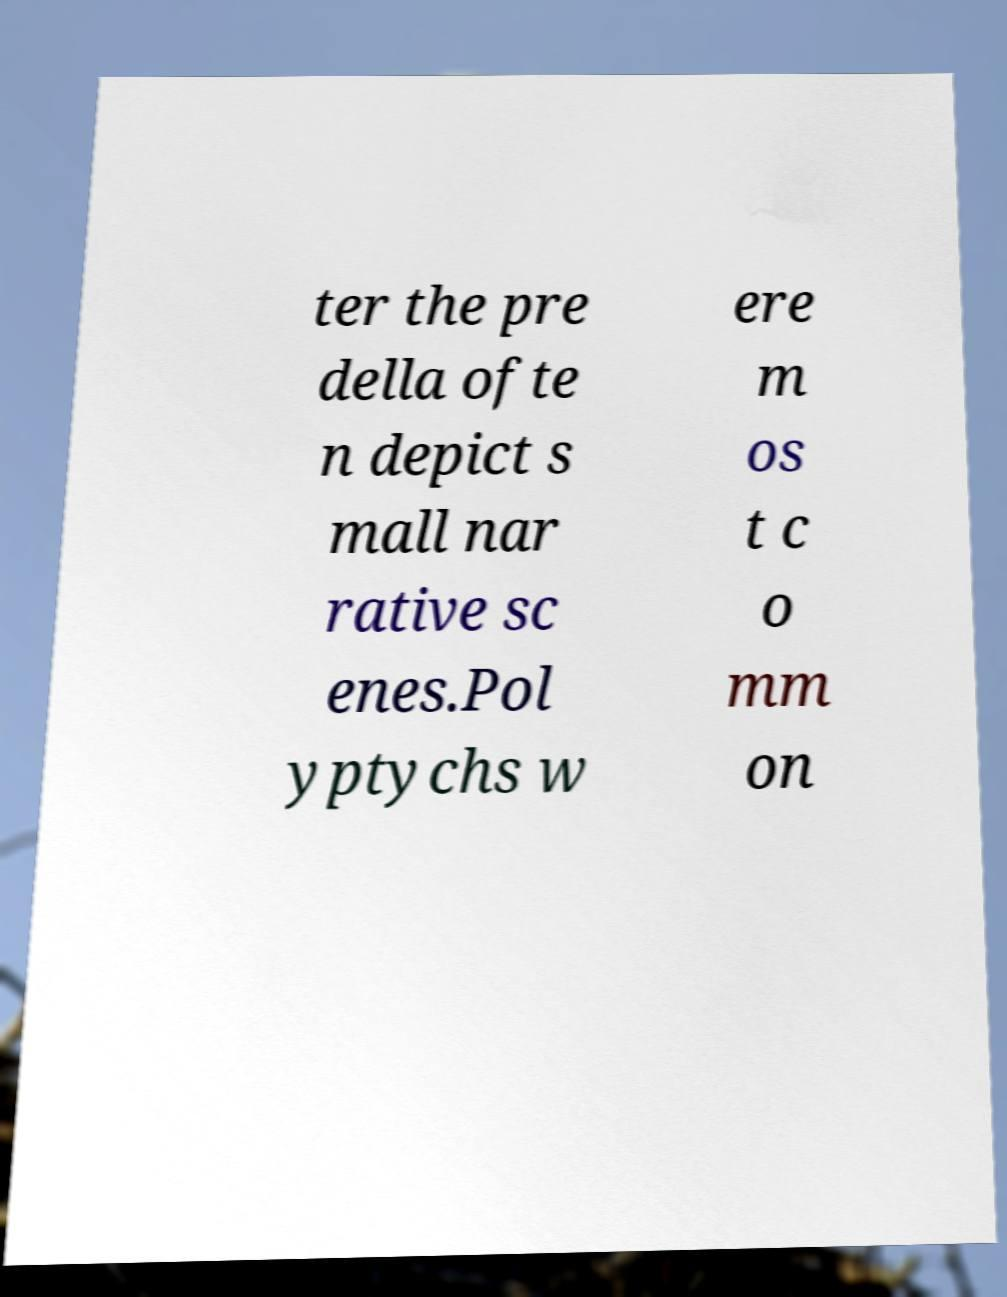I need the written content from this picture converted into text. Can you do that? ter the pre della ofte n depict s mall nar rative sc enes.Pol yptychs w ere m os t c o mm on 